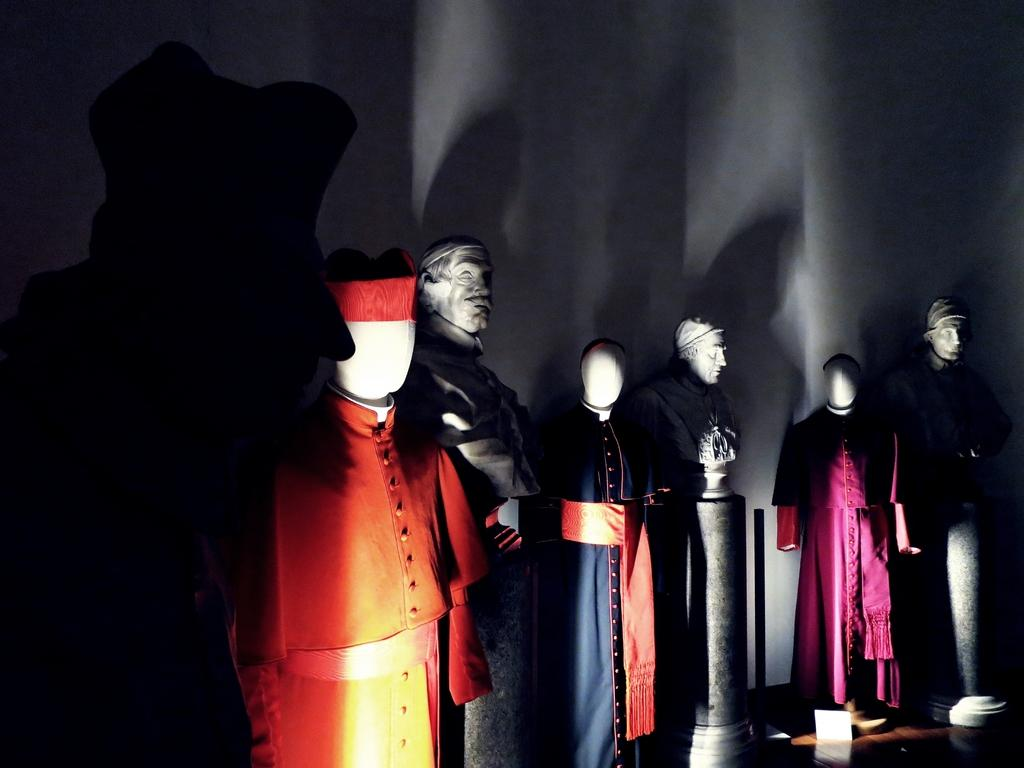What type of objects are dressed in the image? There are mannequins with clothes in the image. What is the background of the image made of? There is a wall in the image. What is the surface on which the mannequins are standing? There is a floor in the image. How does the clover blow in the image? There is no clover present in the image, so it cannot blow. 